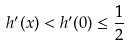Convert formula to latex. <formula><loc_0><loc_0><loc_500><loc_500>h ^ { \prime } ( x ) < h ^ { \prime } ( 0 ) \leq \frac { 1 } { 2 }</formula> 